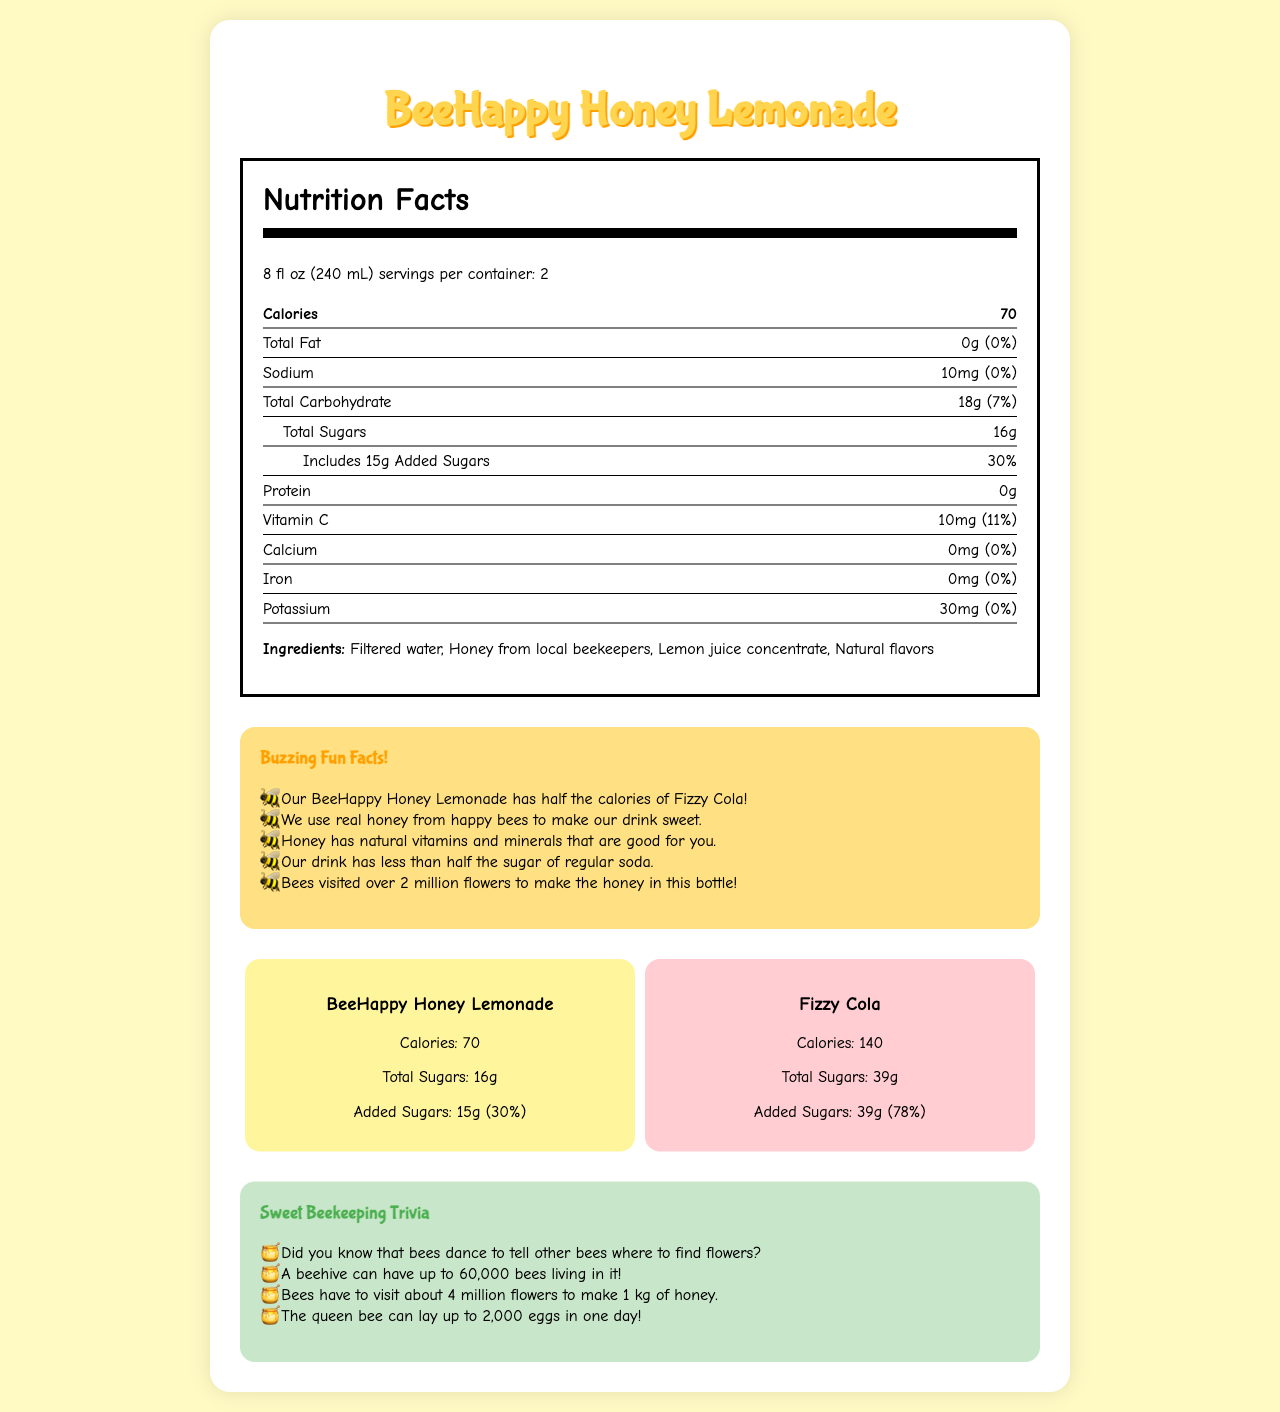what is the serving size for BeeHappy Honey Lemonade? The serving size is listed at the top of the Nutrition Facts section.
Answer: 8 fl oz (240 mL) how many calories are in one serving of BeeHappy Honey Lemonade? The calories per serving are specified as 70 in the Nutrition Facts section.
Answer: 70 what is the amount of added sugars in BeeHappy Honey Lemonade? Under the "Total Sugars" category, the amount of added sugars is noted as 15g.
Answer: 15g how does the sodium content in BeeHappy Honey Lemonade compare to its daily value percentage? The label shows sodium content of 10mg which is 0% of the daily value.
Answer: 10mg, 0% how many grams of protein are there in BeeHappy Honey Lemonade? The protein content is listed as 0g in the Nutrition Facts section.
Answer: 0g which drink has more calories, BeeHappy Honey Lemonade or Fizzy Cola? A. BeeHappy Honey Lemonade B. Fizzy Cola The document states that BeeHappy Honey Lemonade has 70 calories per serving, while Fizzy Cola has 140.
Answer: B what percentage of daily value for Vitamin C does BeeHappy Honey Lemonade provide? A. 7% B. 30% C. 11% D. 0% The percentage of daily value for Vitamin C is noted as 11%.
Answer: C is there any iron in BeeHappy Honey Lemonade? The iron amount is listed as 0mg, which confirms there is no iron present.
Answer: No summarize the main idea of the document. The document highlights the nutritional content of BeeHappy Honey Lemonade, compares it with a regular soda, and shares interesting facts about bees and bee-keeping.
Answer: BeeHappy Honey Lemonade is a healthier alternative to sugary sodas, with lower calories and sugars. It includes natural ingredients like honey and lemon juice and offers nutritional benefits. The document also includes fun bee facts and comparisons to soda. what is the potassium content per serving in BeeHappy Honey Lemonade? The potassium amount is listed as 30mg in the Nutrition Facts section.
Answer: 30mg how many total carbohydrates are in BeeHappy Honey Lemonade per serving? The total carbohydrates amount is listed as 18g in the Nutrition Facts section.
Answer: 18g which drink contains more total sugars, BeeHappy Honey Lemonade or Fizzy Cola? A. BeeHappy Honey Lemonade B. Fizzy Cola BeeHappy Honey Lemonade has 16g of total sugars whereas Fizzy Cola has 39g.
Answer: B how many times more flowers do bees need to visit to make 1 kg of honey compared to the honey in the BeeHappy Honey Lemonade bottle? The exact amount of honey needed in the lemonade bottle is not provided, only that bees visited over 2 million flowers for the bottle is mentioned.
Answer: Cannot be determined how many milligrams of calcium are in one serving of BeeHappy Honey Lemonade? The calcium amount is listed as 0mg in the Nutrition Facts section.
Answer: 0mg do bees dance to communicate with other bees? According to the beekeeping trivia, bees dance to tell other bees where to find flowers.
Answer: Yes how many servings are in one container of BeeHappy Honey Lemonade? The servings per container are listed as 2 in the Nutrition Facts section.
Answer: 2 